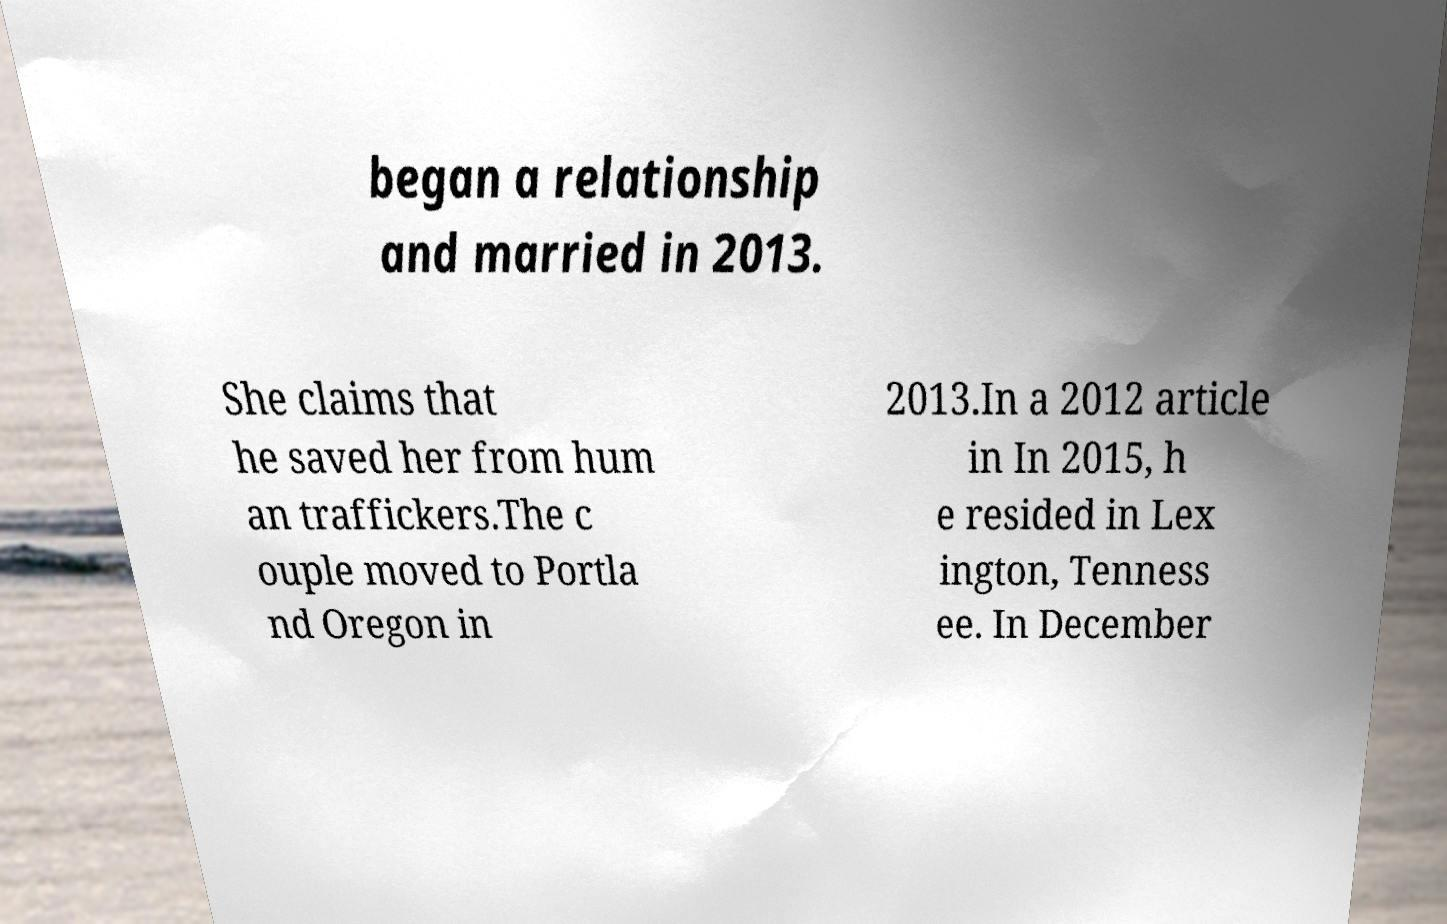Can you read and provide the text displayed in the image?This photo seems to have some interesting text. Can you extract and type it out for me? began a relationship and married in 2013. She claims that he saved her from hum an traffickers.The c ouple moved to Portla nd Oregon in 2013.In a 2012 article in In 2015, h e resided in Lex ington, Tenness ee. In December 